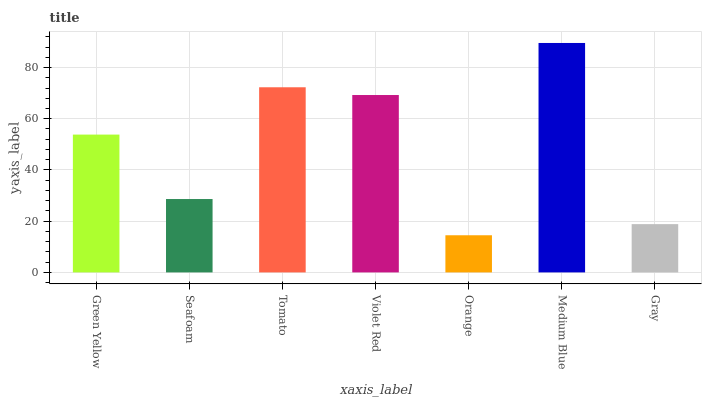Is Seafoam the minimum?
Answer yes or no. No. Is Seafoam the maximum?
Answer yes or no. No. Is Green Yellow greater than Seafoam?
Answer yes or no. Yes. Is Seafoam less than Green Yellow?
Answer yes or no. Yes. Is Seafoam greater than Green Yellow?
Answer yes or no. No. Is Green Yellow less than Seafoam?
Answer yes or no. No. Is Green Yellow the high median?
Answer yes or no. Yes. Is Green Yellow the low median?
Answer yes or no. Yes. Is Seafoam the high median?
Answer yes or no. No. Is Seafoam the low median?
Answer yes or no. No. 